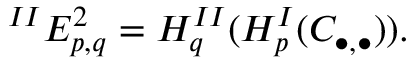Convert formula to latex. <formula><loc_0><loc_0><loc_500><loc_500>{ } ^ { I I } E _ { p , q } ^ { 2 } = H _ { q } ^ { I I } ( H _ { p } ^ { I } ( C _ { \bullet , \bullet } ) ) .</formula> 